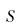Convert formula to latex. <formula><loc_0><loc_0><loc_500><loc_500>S</formula> 